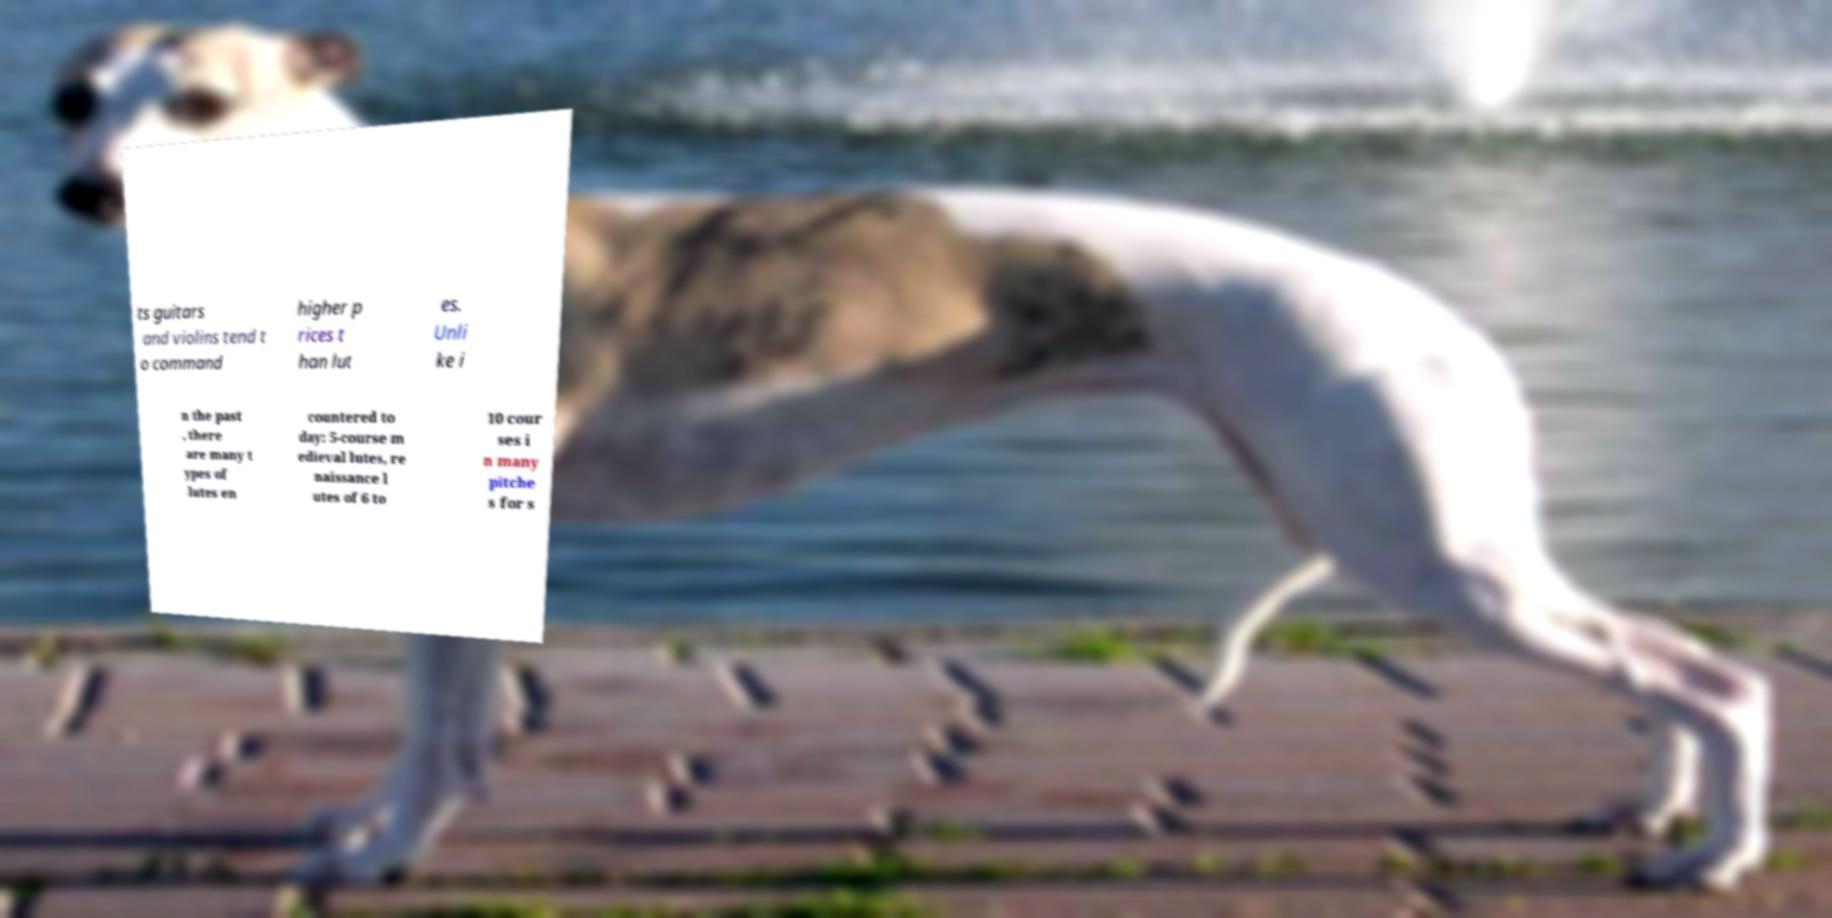For documentation purposes, I need the text within this image transcribed. Could you provide that? ts guitars and violins tend t o command higher p rices t han lut es. Unli ke i n the past , there are many t ypes of lutes en countered to day: 5-course m edieval lutes, re naissance l utes of 6 to 10 cour ses i n many pitche s for s 